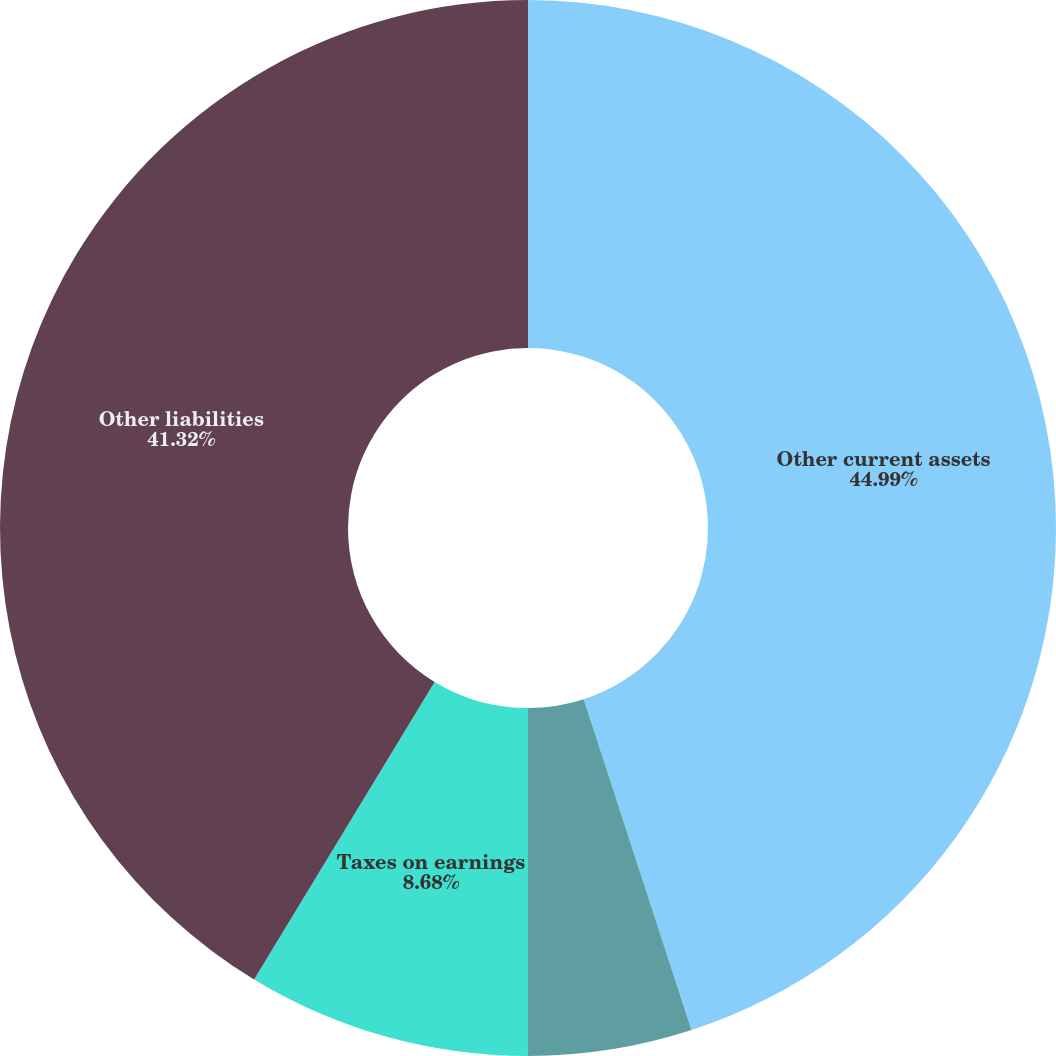Convert chart. <chart><loc_0><loc_0><loc_500><loc_500><pie_chart><fcel>Other current assets<fcel>Long-term financing<fcel>Taxes on earnings<fcel>Other liabilities<nl><fcel>44.99%<fcel>5.01%<fcel>8.68%<fcel>41.32%<nl></chart> 